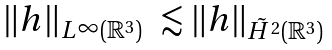Convert formula to latex. <formula><loc_0><loc_0><loc_500><loc_500>\begin{array} { l l } \| h \| _ { L ^ { \infty } ( \mathbb { R } ^ { 3 } ) } & \lesssim \| h \| _ { \tilde { H } ^ { 2 } ( \mathbb { R } ^ { 3 } ) } \end{array}</formula> 